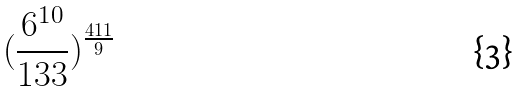Convert formula to latex. <formula><loc_0><loc_0><loc_500><loc_500>( \frac { 6 ^ { 1 0 } } { 1 3 3 } ) ^ { \frac { 4 1 1 } { 9 } }</formula> 